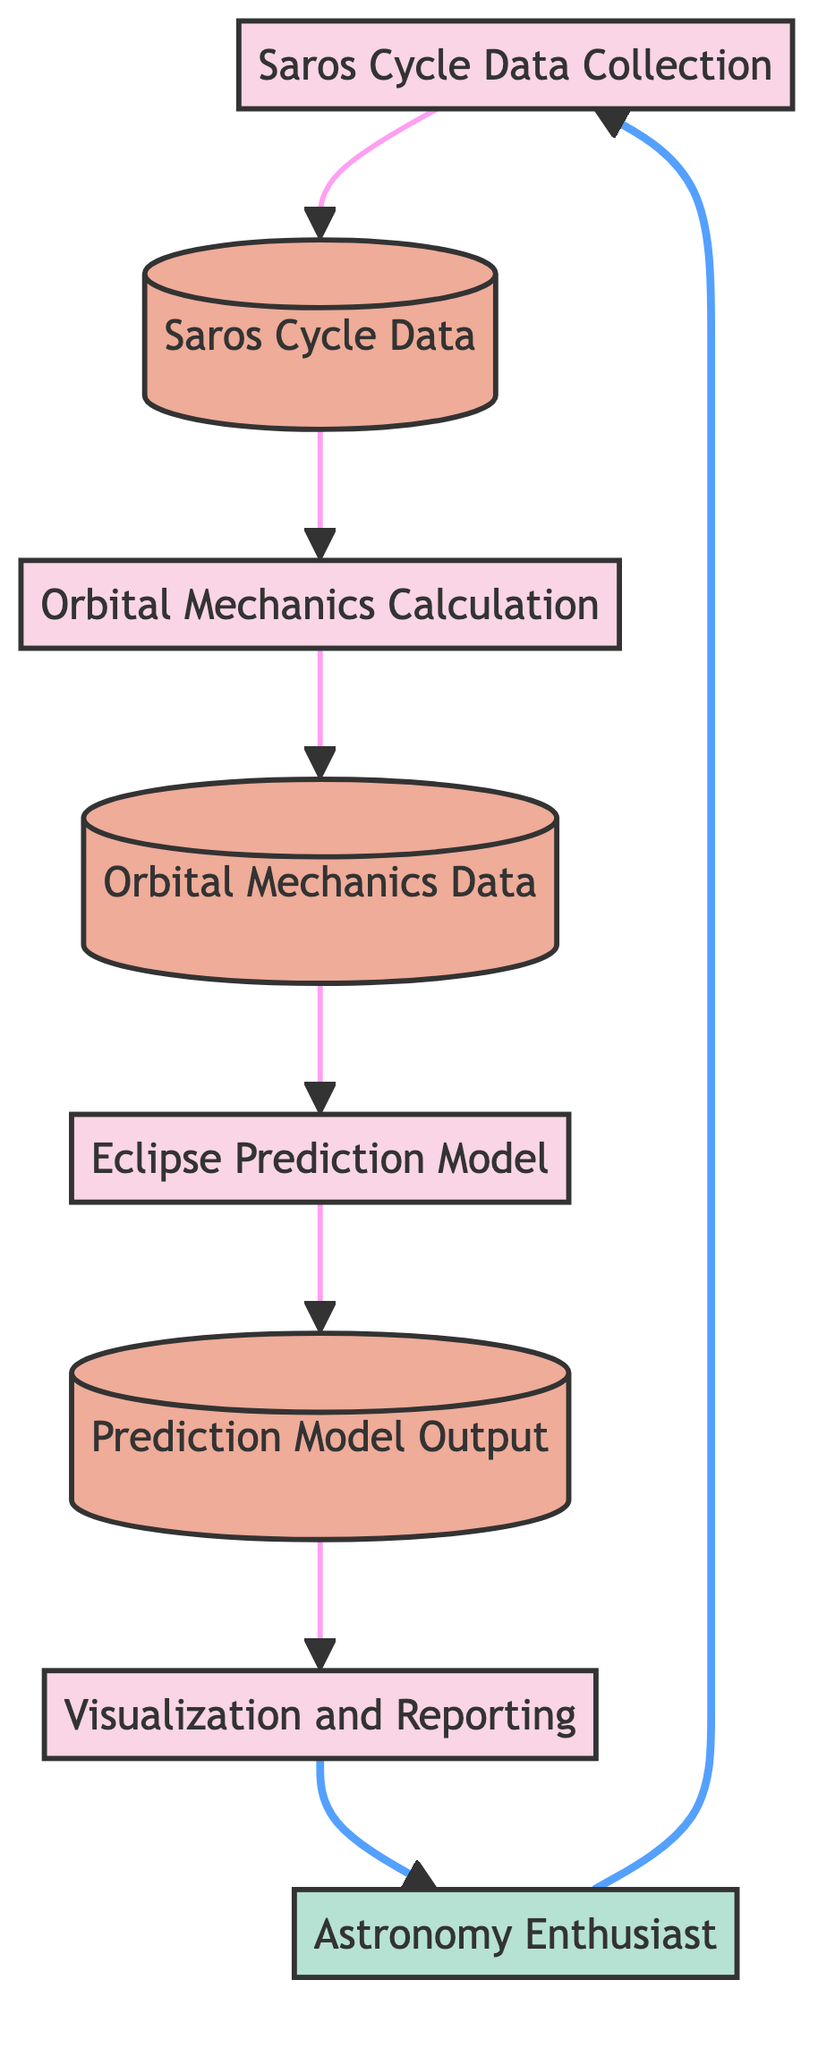What is the first process in the diagram? The first process listed in the diagram is "Saros Cycle Data Collection," which is represented as node 1. This is established by examining the labeled processes in a top-down order.
Answer: Saros Cycle Data Collection What type of data does the "Orbital Mechanics Calculation" process receive? The "Orbital Mechanics Calculation" process receives data from "Saros Cycle Data," specifically taking as input historical eclipse data that has been collected. This is indicated by the data flow from the store labeled A to the process labeled 2.
Answer: Saros Cycle Data How many total processes are represented in the diagram? The diagram includes four distinct processes: "Saros Cycle Data Collection," "Orbital Mechanics Calculation," "Eclipse Prediction Model," and "Visualization and Reporting." This is determined by counting the labeled processes.
Answer: 4 What data store does the "Eclipse Prediction Model" use? The "Eclipse Prediction Model" uses "Orbital Mechanics Data," as indicated by the input arrow directing from the process labeled 2 to the data store labeled B. This means the model relies on geometric arrangements derived from the previous computations.
Answer: Orbital Mechanics Data Which external entity interacts with the flow of data? The external entity is "Astronomy Enthusiast," who starts the data flow and receives the final output. This is clearly shown at both ends of the diagram where the arrow starts from and points to this entity.
Answer: Astronomy Enthusiast What is the output of the "Eclipse Prediction Model"? The output of the "Eclipse Prediction Model" is "Prediction Model Output," which is stored and then used for the next step of visualization in the diagram. The output is directly derived from the model's processing.
Answer: Prediction Model Output Which process generates visualizations? The process that generates visualizations is "Visualization and Reporting," identified as the last step in the flow, which takes as input the "Prediction Model Output." This is indicated by the flow coming from the output data store to the final process.
Answer: Visualization and Reporting What type of data does the "Visualization and Reporting" process receive? The "Visualization and Reporting" process receives "Prediction Model Output" as the input data, which is a product of the preceding process in the diagram. This input is essential for creating the visual representations of the lunar eclipses.
Answer: Prediction Model Output 